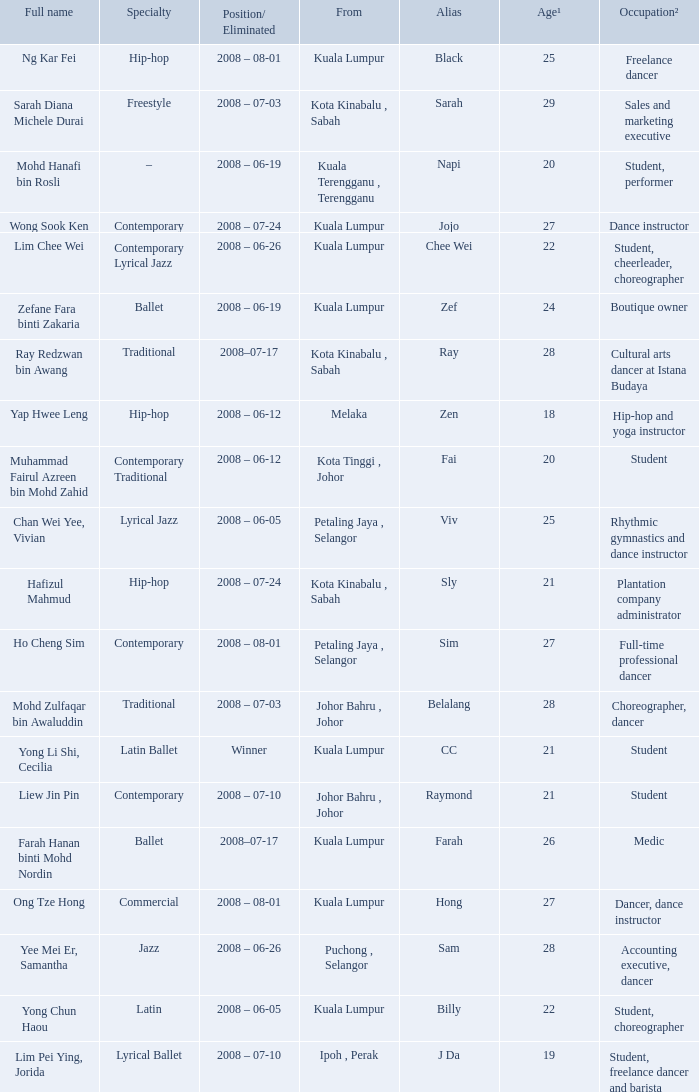What is Position/ Eliminated, when Age¹ is less than 22, and when Full Name is "Muhammad Fairul Azreen Bin Mohd Zahid"? 2008 – 06-12. 